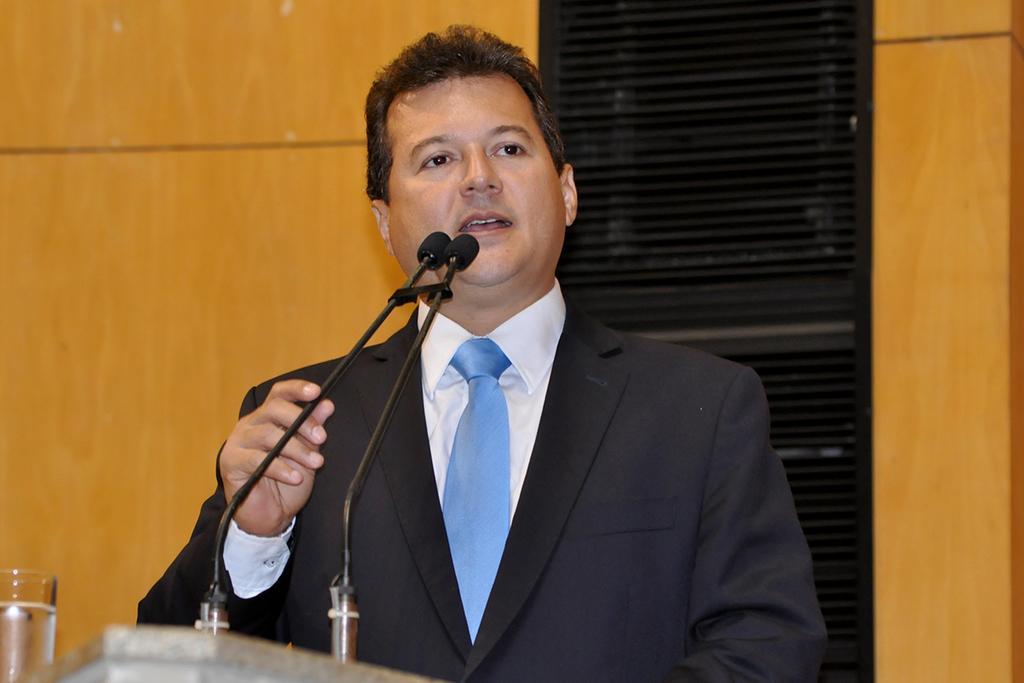How would you summarize this image in a sentence or two? As we can see in the image there is a yellow color wall and a man standing over here. In front of him there is a mike. 